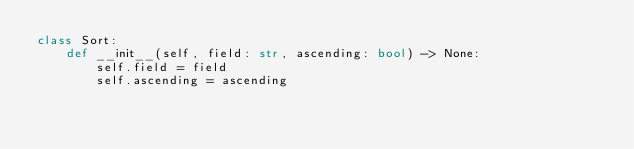<code> <loc_0><loc_0><loc_500><loc_500><_Python_>class Sort:
    def __init__(self, field: str, ascending: bool) -> None:
        self.field = field
        self.ascending = ascending
</code> 